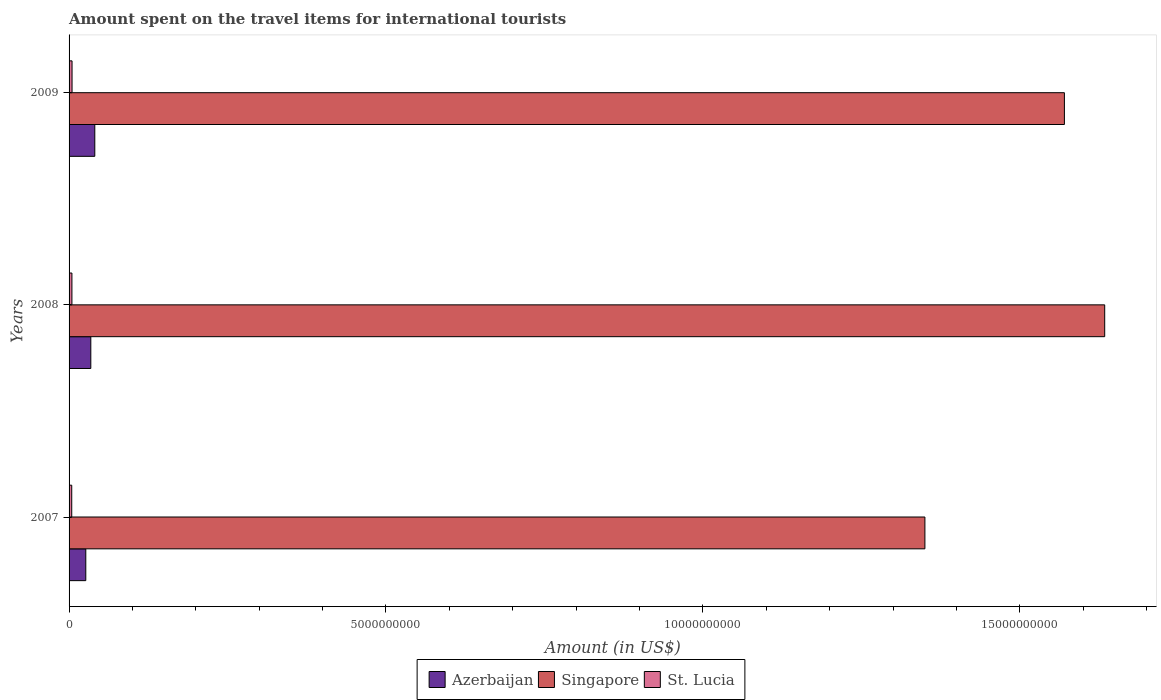How many groups of bars are there?
Ensure brevity in your answer.  3. What is the amount spent on the travel items for international tourists in Singapore in 2007?
Ensure brevity in your answer.  1.35e+1. Across all years, what is the maximum amount spent on the travel items for international tourists in Singapore?
Your answer should be very brief. 1.63e+1. Across all years, what is the minimum amount spent on the travel items for international tourists in Azerbaijan?
Ensure brevity in your answer.  2.64e+08. In which year was the amount spent on the travel items for international tourists in Singapore minimum?
Your answer should be compact. 2007. What is the total amount spent on the travel items for international tourists in Singapore in the graph?
Provide a succinct answer. 4.55e+1. What is the difference between the amount spent on the travel items for international tourists in Singapore in 2007 and that in 2009?
Ensure brevity in your answer.  -2.20e+09. What is the difference between the amount spent on the travel items for international tourists in Singapore in 2008 and the amount spent on the travel items for international tourists in Azerbaijan in 2007?
Give a very brief answer. 1.61e+1. What is the average amount spent on the travel items for international tourists in St. Lucia per year?
Offer a very short reply. 4.47e+07. In the year 2009, what is the difference between the amount spent on the travel items for international tourists in Singapore and amount spent on the travel items for international tourists in St. Lucia?
Make the answer very short. 1.57e+1. What is the ratio of the amount spent on the travel items for international tourists in Azerbaijan in 2008 to that in 2009?
Make the answer very short. 0.84. Is the amount spent on the travel items for international tourists in Azerbaijan in 2007 less than that in 2008?
Offer a very short reply. Yes. Is the difference between the amount spent on the travel items for international tourists in Singapore in 2008 and 2009 greater than the difference between the amount spent on the travel items for international tourists in St. Lucia in 2008 and 2009?
Keep it short and to the point. Yes. What is the difference between the highest and the lowest amount spent on the travel items for international tourists in Azerbaijan?
Provide a short and direct response. 1.42e+08. Is the sum of the amount spent on the travel items for international tourists in St. Lucia in 2008 and 2009 greater than the maximum amount spent on the travel items for international tourists in Singapore across all years?
Offer a terse response. No. What does the 1st bar from the top in 2009 represents?
Your answer should be very brief. St. Lucia. What does the 3rd bar from the bottom in 2007 represents?
Your answer should be compact. St. Lucia. Are all the bars in the graph horizontal?
Offer a terse response. Yes. What is the difference between two consecutive major ticks on the X-axis?
Provide a succinct answer. 5.00e+09. Are the values on the major ticks of X-axis written in scientific E-notation?
Provide a succinct answer. No. Does the graph contain any zero values?
Offer a very short reply. No. Where does the legend appear in the graph?
Make the answer very short. Bottom center. What is the title of the graph?
Your answer should be very brief. Amount spent on the travel items for international tourists. Does "Samoa" appear as one of the legend labels in the graph?
Keep it short and to the point. No. What is the label or title of the X-axis?
Make the answer very short. Amount (in US$). What is the label or title of the Y-axis?
Your answer should be very brief. Years. What is the Amount (in US$) in Azerbaijan in 2007?
Make the answer very short. 2.64e+08. What is the Amount (in US$) of Singapore in 2007?
Your answer should be compact. 1.35e+1. What is the Amount (in US$) of St. Lucia in 2007?
Offer a very short reply. 4.20e+07. What is the Amount (in US$) in Azerbaijan in 2008?
Offer a very short reply. 3.43e+08. What is the Amount (in US$) of Singapore in 2008?
Provide a succinct answer. 1.63e+1. What is the Amount (in US$) of St. Lucia in 2008?
Provide a succinct answer. 4.50e+07. What is the Amount (in US$) in Azerbaijan in 2009?
Your answer should be very brief. 4.06e+08. What is the Amount (in US$) of Singapore in 2009?
Give a very brief answer. 1.57e+1. What is the Amount (in US$) in St. Lucia in 2009?
Offer a terse response. 4.70e+07. Across all years, what is the maximum Amount (in US$) in Azerbaijan?
Ensure brevity in your answer.  4.06e+08. Across all years, what is the maximum Amount (in US$) in Singapore?
Make the answer very short. 1.63e+1. Across all years, what is the maximum Amount (in US$) of St. Lucia?
Your response must be concise. 4.70e+07. Across all years, what is the minimum Amount (in US$) in Azerbaijan?
Make the answer very short. 2.64e+08. Across all years, what is the minimum Amount (in US$) of Singapore?
Give a very brief answer. 1.35e+1. Across all years, what is the minimum Amount (in US$) in St. Lucia?
Make the answer very short. 4.20e+07. What is the total Amount (in US$) of Azerbaijan in the graph?
Provide a short and direct response. 1.01e+09. What is the total Amount (in US$) in Singapore in the graph?
Make the answer very short. 4.55e+1. What is the total Amount (in US$) in St. Lucia in the graph?
Your response must be concise. 1.34e+08. What is the difference between the Amount (in US$) in Azerbaijan in 2007 and that in 2008?
Your answer should be very brief. -7.90e+07. What is the difference between the Amount (in US$) in Singapore in 2007 and that in 2008?
Your answer should be very brief. -2.84e+09. What is the difference between the Amount (in US$) in St. Lucia in 2007 and that in 2008?
Make the answer very short. -3.00e+06. What is the difference between the Amount (in US$) in Azerbaijan in 2007 and that in 2009?
Make the answer very short. -1.42e+08. What is the difference between the Amount (in US$) of Singapore in 2007 and that in 2009?
Give a very brief answer. -2.20e+09. What is the difference between the Amount (in US$) in St. Lucia in 2007 and that in 2009?
Offer a terse response. -5.00e+06. What is the difference between the Amount (in US$) in Azerbaijan in 2008 and that in 2009?
Provide a short and direct response. -6.30e+07. What is the difference between the Amount (in US$) in Singapore in 2008 and that in 2009?
Offer a very short reply. 6.36e+08. What is the difference between the Amount (in US$) of Azerbaijan in 2007 and the Amount (in US$) of Singapore in 2008?
Ensure brevity in your answer.  -1.61e+1. What is the difference between the Amount (in US$) of Azerbaijan in 2007 and the Amount (in US$) of St. Lucia in 2008?
Give a very brief answer. 2.19e+08. What is the difference between the Amount (in US$) in Singapore in 2007 and the Amount (in US$) in St. Lucia in 2008?
Offer a terse response. 1.35e+1. What is the difference between the Amount (in US$) of Azerbaijan in 2007 and the Amount (in US$) of Singapore in 2009?
Your response must be concise. -1.54e+1. What is the difference between the Amount (in US$) of Azerbaijan in 2007 and the Amount (in US$) of St. Lucia in 2009?
Your response must be concise. 2.17e+08. What is the difference between the Amount (in US$) of Singapore in 2007 and the Amount (in US$) of St. Lucia in 2009?
Give a very brief answer. 1.35e+1. What is the difference between the Amount (in US$) in Azerbaijan in 2008 and the Amount (in US$) in Singapore in 2009?
Provide a succinct answer. -1.54e+1. What is the difference between the Amount (in US$) of Azerbaijan in 2008 and the Amount (in US$) of St. Lucia in 2009?
Offer a very short reply. 2.96e+08. What is the difference between the Amount (in US$) in Singapore in 2008 and the Amount (in US$) in St. Lucia in 2009?
Your response must be concise. 1.63e+1. What is the average Amount (in US$) in Azerbaijan per year?
Offer a terse response. 3.38e+08. What is the average Amount (in US$) in Singapore per year?
Offer a very short reply. 1.52e+1. What is the average Amount (in US$) in St. Lucia per year?
Your answer should be compact. 4.47e+07. In the year 2007, what is the difference between the Amount (in US$) of Azerbaijan and Amount (in US$) of Singapore?
Your answer should be very brief. -1.32e+1. In the year 2007, what is the difference between the Amount (in US$) in Azerbaijan and Amount (in US$) in St. Lucia?
Offer a terse response. 2.22e+08. In the year 2007, what is the difference between the Amount (in US$) of Singapore and Amount (in US$) of St. Lucia?
Provide a short and direct response. 1.35e+1. In the year 2008, what is the difference between the Amount (in US$) in Azerbaijan and Amount (in US$) in Singapore?
Ensure brevity in your answer.  -1.60e+1. In the year 2008, what is the difference between the Amount (in US$) of Azerbaijan and Amount (in US$) of St. Lucia?
Your response must be concise. 2.98e+08. In the year 2008, what is the difference between the Amount (in US$) of Singapore and Amount (in US$) of St. Lucia?
Provide a succinct answer. 1.63e+1. In the year 2009, what is the difference between the Amount (in US$) in Azerbaijan and Amount (in US$) in Singapore?
Make the answer very short. -1.53e+1. In the year 2009, what is the difference between the Amount (in US$) in Azerbaijan and Amount (in US$) in St. Lucia?
Offer a terse response. 3.59e+08. In the year 2009, what is the difference between the Amount (in US$) of Singapore and Amount (in US$) of St. Lucia?
Give a very brief answer. 1.57e+1. What is the ratio of the Amount (in US$) of Azerbaijan in 2007 to that in 2008?
Your answer should be compact. 0.77. What is the ratio of the Amount (in US$) in Singapore in 2007 to that in 2008?
Your answer should be very brief. 0.83. What is the ratio of the Amount (in US$) of Azerbaijan in 2007 to that in 2009?
Your answer should be very brief. 0.65. What is the ratio of the Amount (in US$) of Singapore in 2007 to that in 2009?
Offer a terse response. 0.86. What is the ratio of the Amount (in US$) in St. Lucia in 2007 to that in 2009?
Provide a succinct answer. 0.89. What is the ratio of the Amount (in US$) of Azerbaijan in 2008 to that in 2009?
Make the answer very short. 0.84. What is the ratio of the Amount (in US$) in Singapore in 2008 to that in 2009?
Make the answer very short. 1.04. What is the ratio of the Amount (in US$) of St. Lucia in 2008 to that in 2009?
Provide a succinct answer. 0.96. What is the difference between the highest and the second highest Amount (in US$) in Azerbaijan?
Ensure brevity in your answer.  6.30e+07. What is the difference between the highest and the second highest Amount (in US$) of Singapore?
Give a very brief answer. 6.36e+08. What is the difference between the highest and the lowest Amount (in US$) in Azerbaijan?
Ensure brevity in your answer.  1.42e+08. What is the difference between the highest and the lowest Amount (in US$) of Singapore?
Provide a succinct answer. 2.84e+09. 